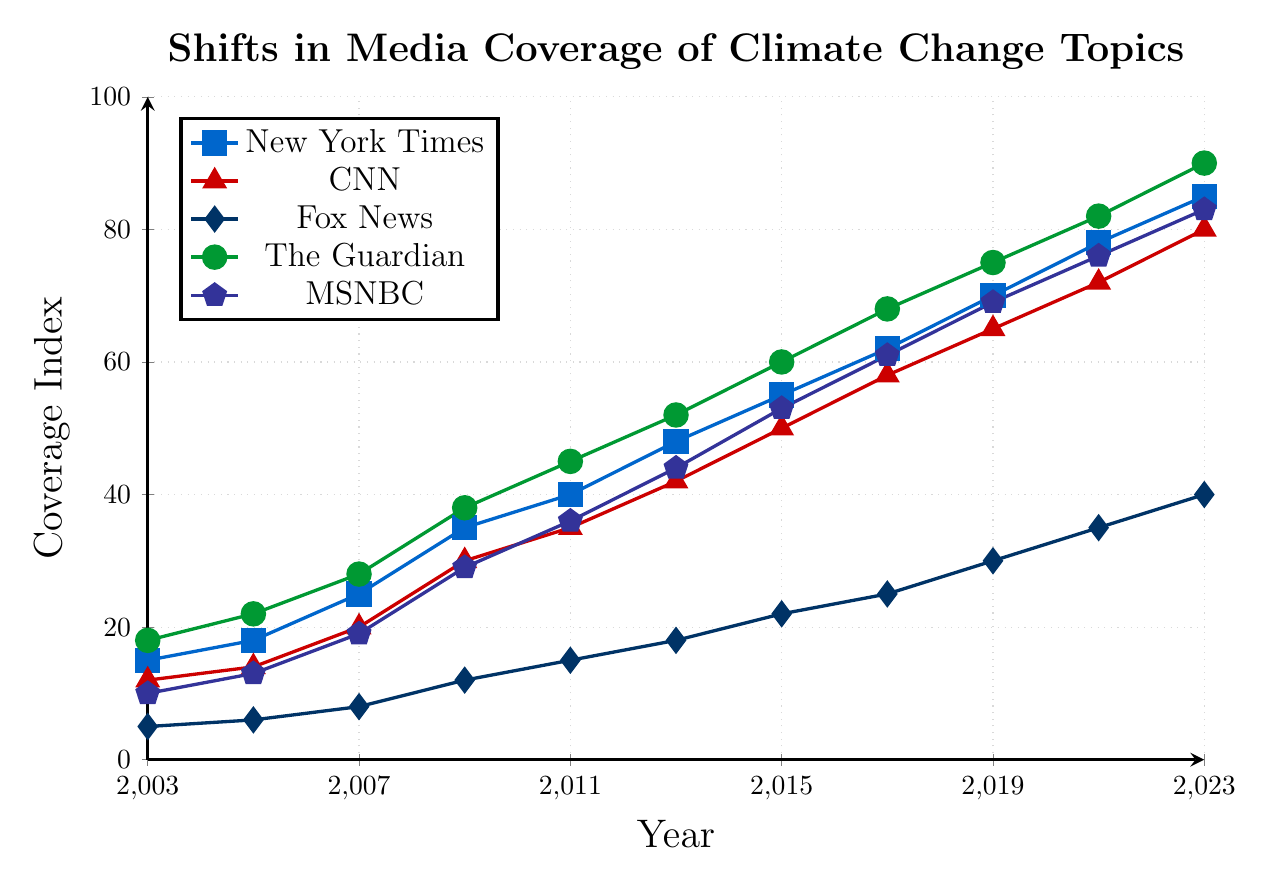Which news outlet had the highest coverage index in 2023? Looking at the rightmost values of each line in the chart, The Guardian's line reaches the highest point on the y-axis in 2023.
Answer: The Guardian How did CNN's coverage index change from 2003 to 2023? Starting from the CNN value in 2003 (12) and comparing it with the CNN value in 2023 (80), the difference is 80 - 12 = 68.
Answer: Increased by 68 Which outlet showed the least coverage of climate change in 2009? In 2009, Fox News has the lowest point on the y-axis compared to other outlets at a coverage index of 12.
Answer: Fox News What is the average coverage index of the New York Times from 2003 to 2023? Sum the New York Times coverage index values over the years (15 + 18 + 25 + 35 + 40 + 48 + 55 + 62 + 70 + 78 + 85) = 531. Divide by the number of years (11). 531 / 11 ≈ 48.3.
Answer: Approximately 48.3 Did any news outlet have a coverage index increase that was equal to or greater than 70 from 2003 to 2023? Comparing the differences for all outlets: 
The Guardian: 90 - 18 = 72;
New York Times: 85 - 15 = 70;
CNN: 80 - 12 = 68;
MSNBC: 83 - 10 = 73;
Fox News: 40 - 5 = 35.
The Guardian and MSNBC have increases equal to or above 70.
Answer: The Guardian, MSNBC By what percentage did MSNBC’s coverage index increase from 2003 to 2023? Initial value in 2003 was 10, and the final value in 2023 was 83. The percentage increase is (83 - 10) / 10 * 100% = 730%.
Answer: 730% Which news outlet showed the smallest relative increase in coverage index from 2011 to 2023? Calculating relative increases:
New York Times: (85-40)/40 = 1.125≈112.5%;
CNN: (80-35)/35 = 1.285≈128.5%;
Fox News: (40-15)/15 = 1.667≈166.7%;
The Guardian: (90-45)/45 = 1.0=100%;
MSNBC: (83-36)/36 = 1.306≈130.6%.
The smallest relative increase is for The Guardian.
Answer: The Guardian Compare the coverage indexes of Fox News and The Guardian in 2009, and state the difference. Fox News coverage index in 2009 was 12, and The Guardian’s was 38. The difference is 38 - 12 = 26.
Answer: 26 Which news outlets had an equal coverage index in any given year? By examining the lines, no two outlets have exactly overlapping values in any given year.
Answer: None What is the total increase in coverage index for all outlets from 2003 to 2023? Summing the individual increases:
New York Times: 85 - 15 = 70;
CNN: 80 - 12 = 68;
Fox News: 40 - 5 = 35;
The Guardian: 90 - 18 = 72;
MSNBC: 83 - 10 = 73.
Total increase = 70 + 68 + 35 + 72 + 73 = 318.
Answer: 318 